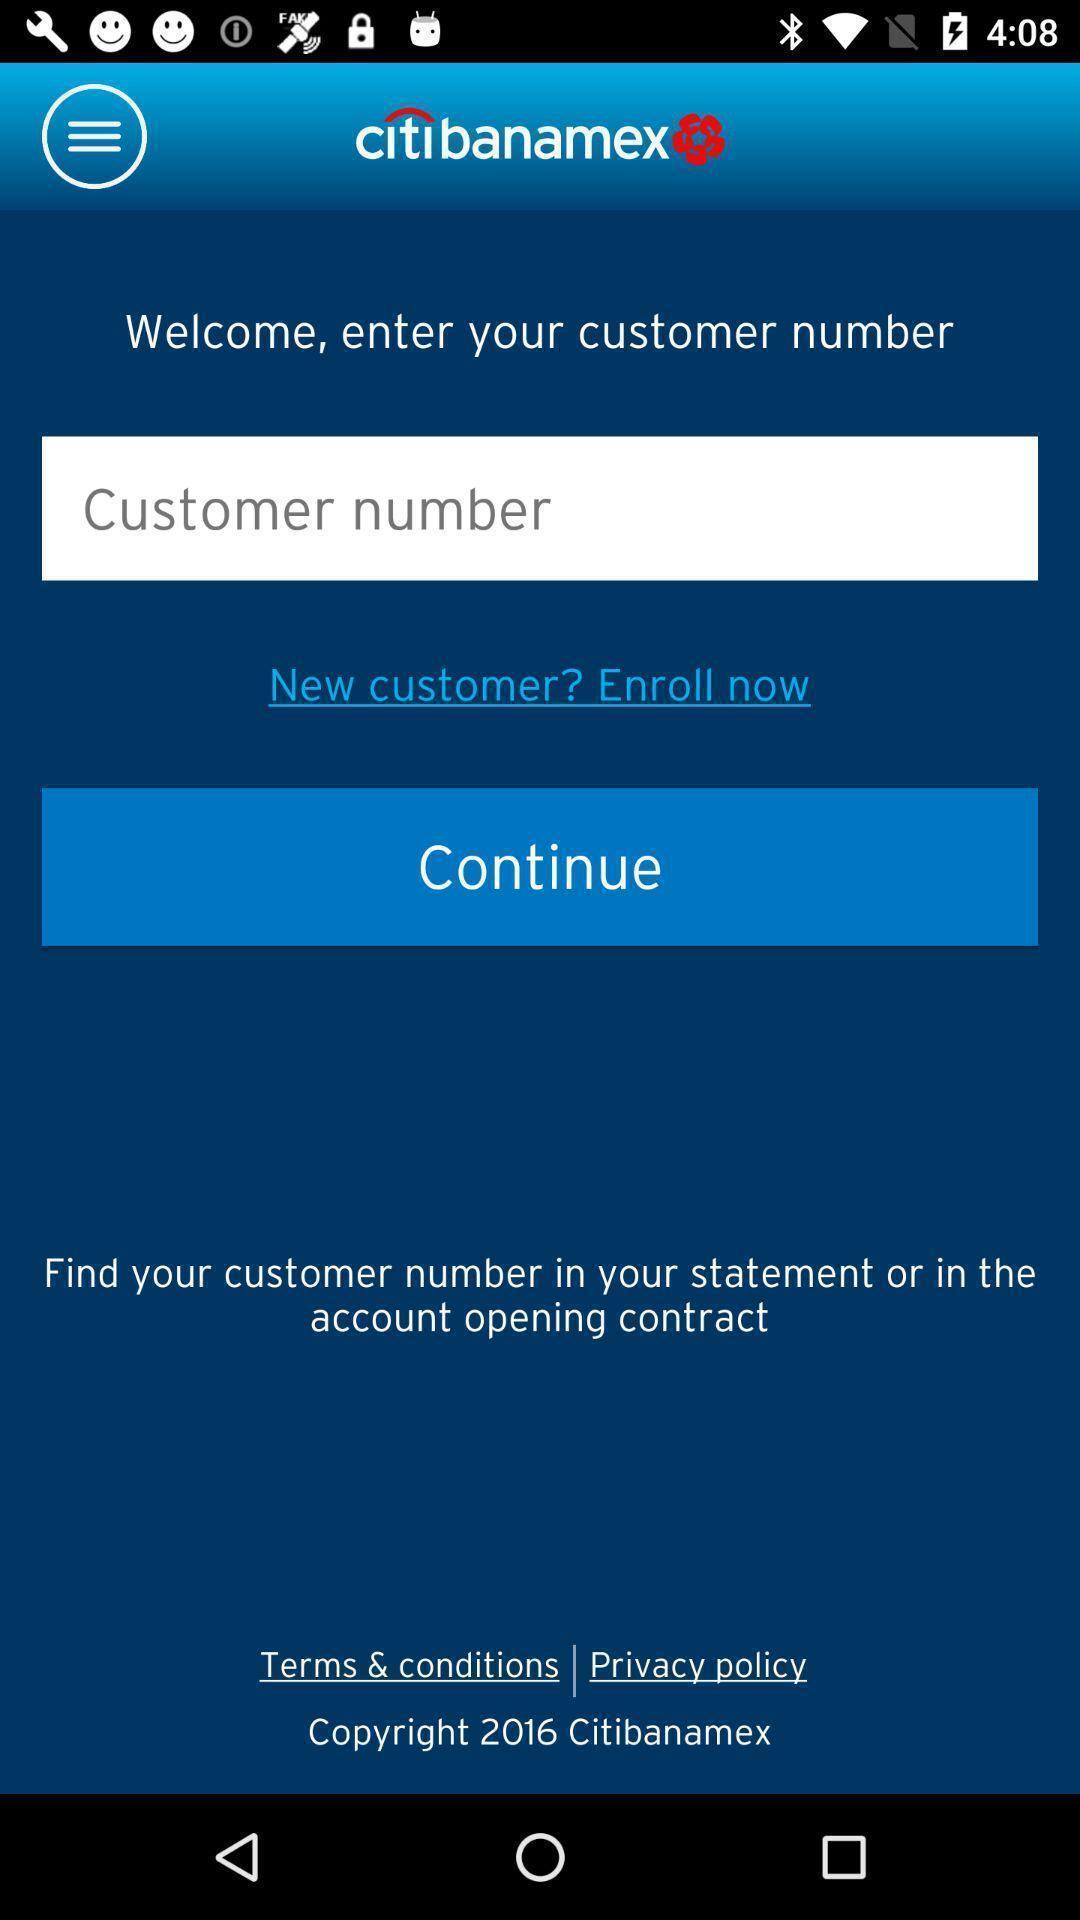Please provide a description for this image. Welcome page of an banking app. 